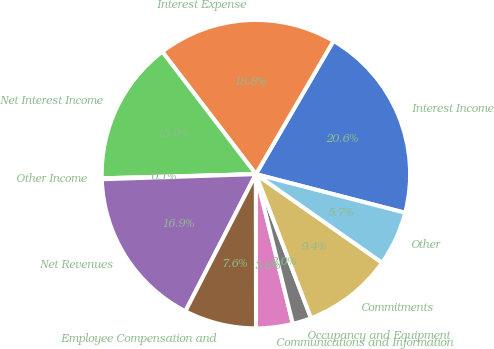Convert chart to OTSL. <chart><loc_0><loc_0><loc_500><loc_500><pie_chart><fcel>Interest Income<fcel>Interest Expense<fcel>Net Interest Income<fcel>Other Income<fcel>Net Revenues<fcel>Employee Compensation and<fcel>Communications and Information<fcel>Occupancy and Equipment<fcel>Commitments<fcel>Other<nl><fcel>20.64%<fcel>18.78%<fcel>15.04%<fcel>0.1%<fcel>16.91%<fcel>7.57%<fcel>3.84%<fcel>1.97%<fcel>9.44%<fcel>5.71%<nl></chart> 